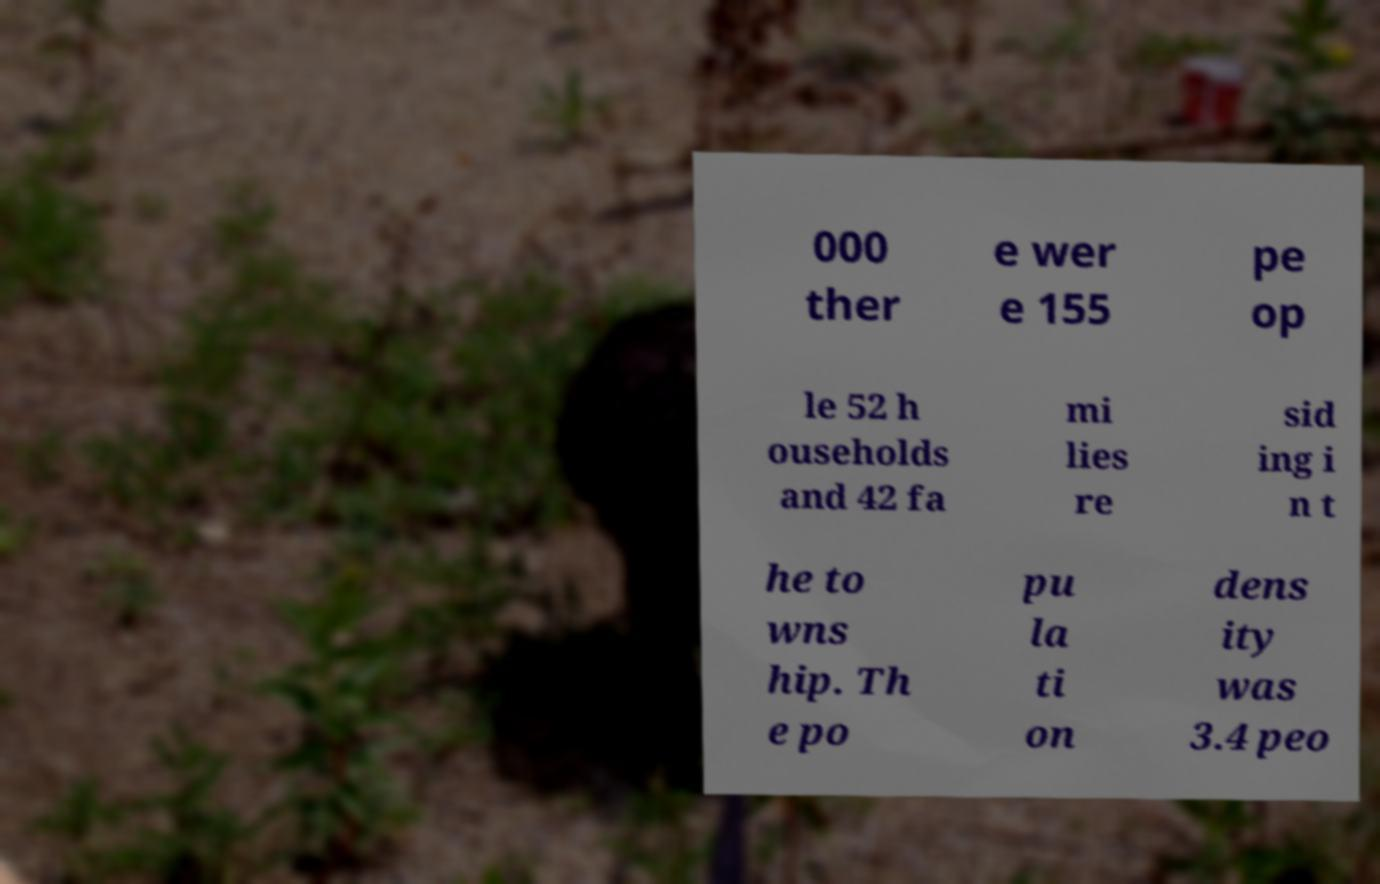Can you read and provide the text displayed in the image?This photo seems to have some interesting text. Can you extract and type it out for me? 000 ther e wer e 155 pe op le 52 h ouseholds and 42 fa mi lies re sid ing i n t he to wns hip. Th e po pu la ti on dens ity was 3.4 peo 